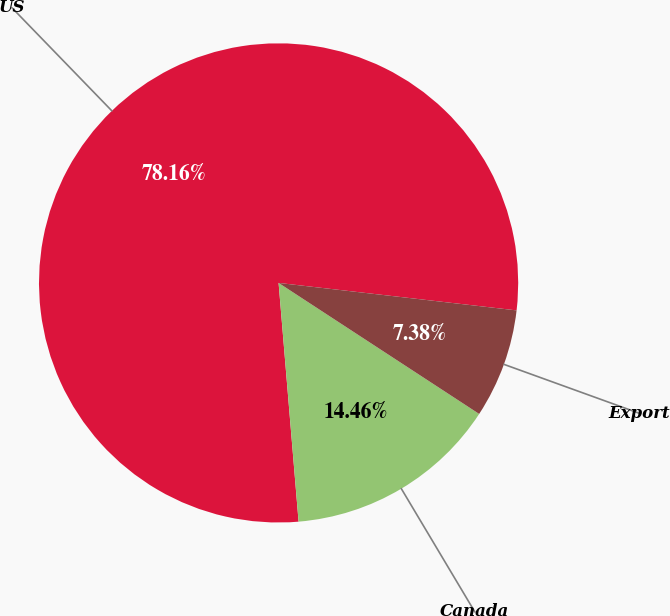<chart> <loc_0><loc_0><loc_500><loc_500><pie_chart><fcel>US<fcel>Canada<fcel>Export<nl><fcel>78.16%<fcel>14.46%<fcel>7.38%<nl></chart> 